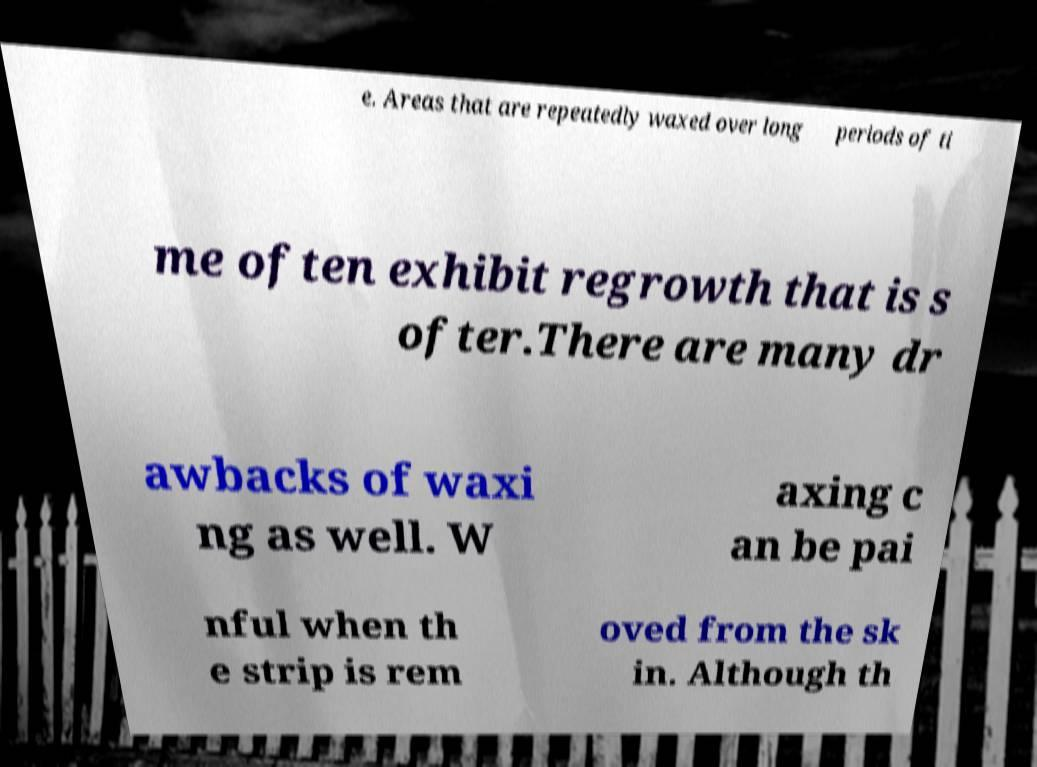There's text embedded in this image that I need extracted. Can you transcribe it verbatim? e. Areas that are repeatedly waxed over long periods of ti me often exhibit regrowth that is s ofter.There are many dr awbacks of waxi ng as well. W axing c an be pai nful when th e strip is rem oved from the sk in. Although th 